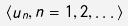Convert formula to latex. <formula><loc_0><loc_0><loc_500><loc_500>\langle u _ { n } , n = 1 , 2 , \dots \rangle</formula> 